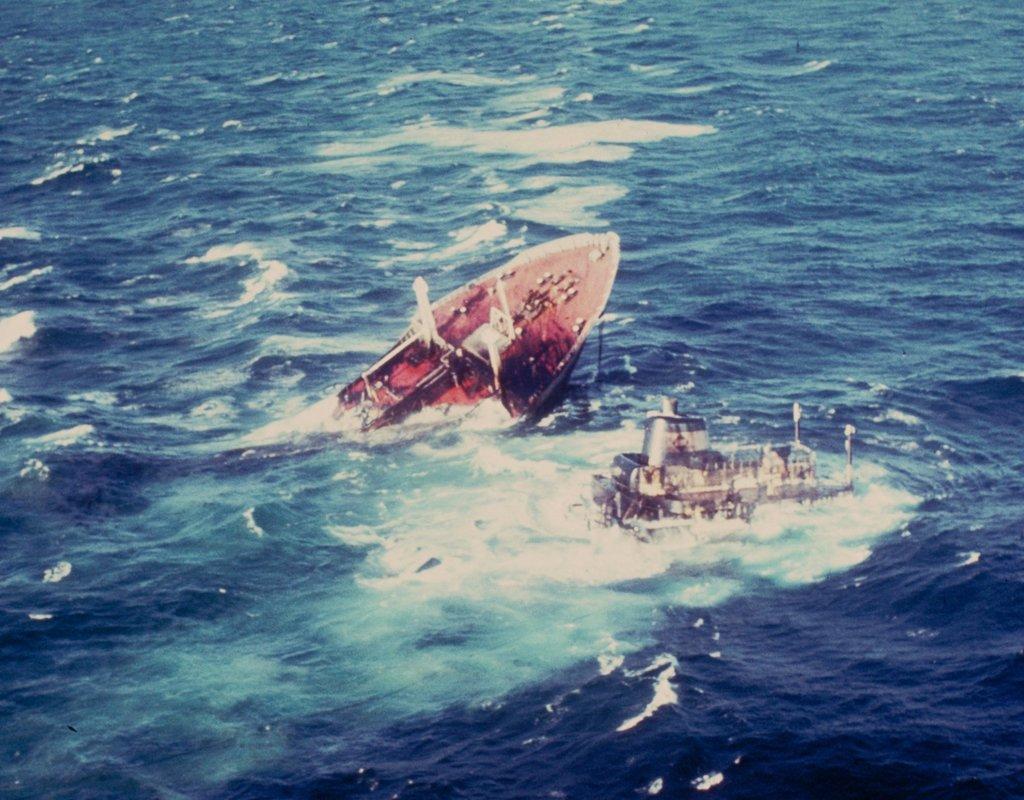Describe this image in one or two sentences. In this picture there are two ships in the center of the image, it seems to be the ships are going into the water and there is water around the area of the image. 